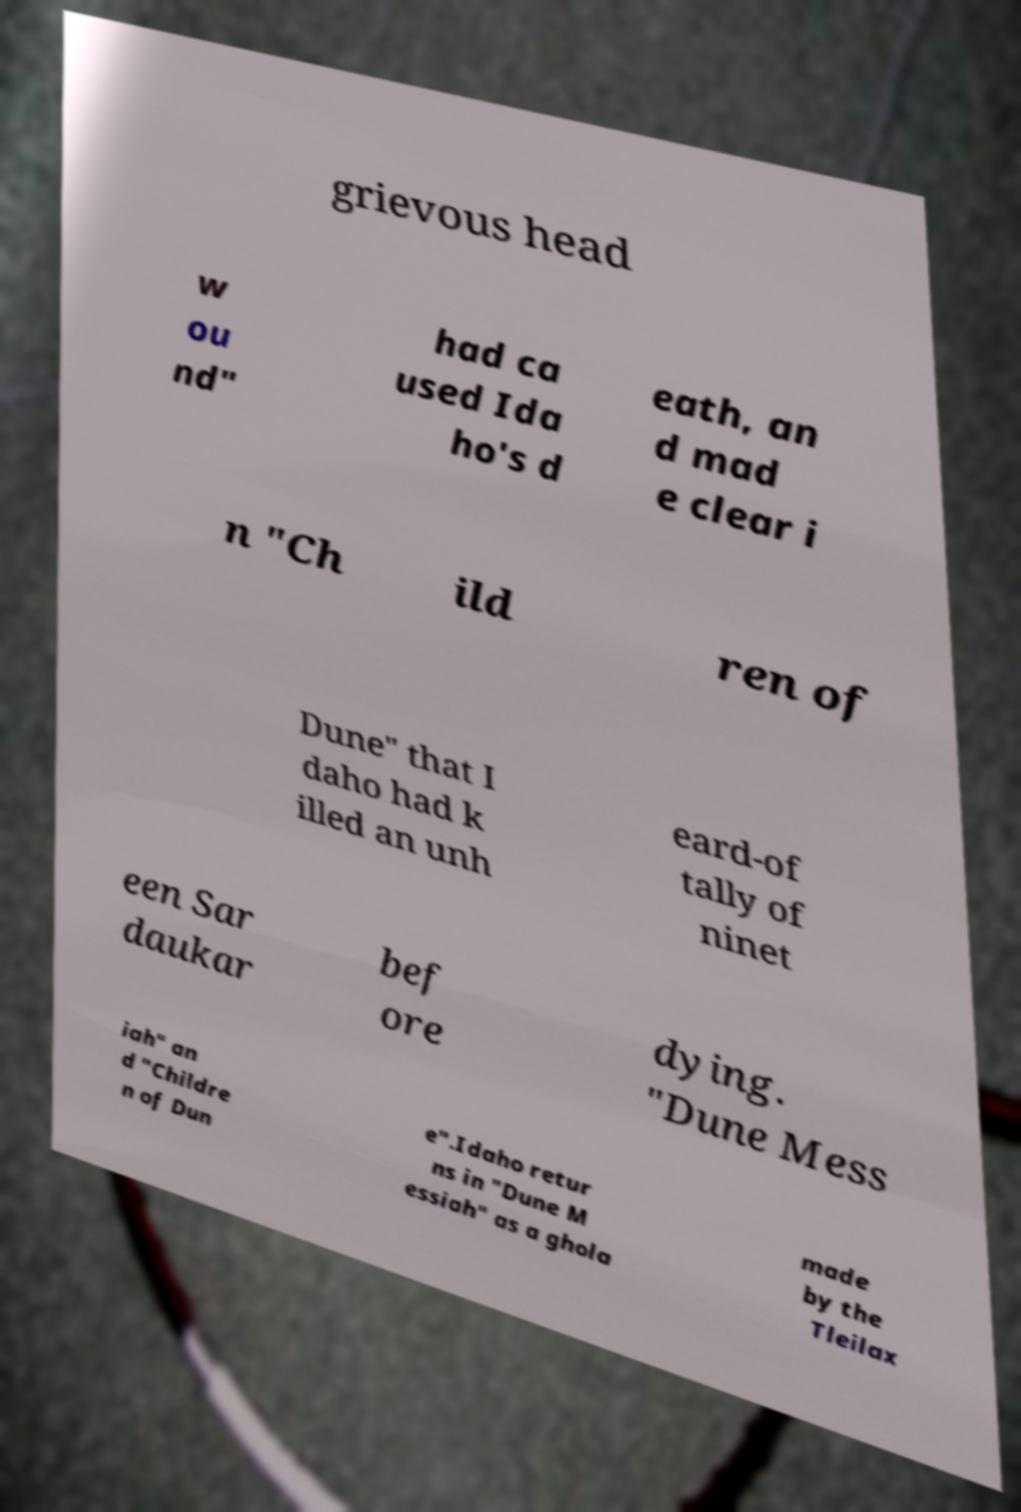Can you accurately transcribe the text from the provided image for me? grievous head w ou nd" had ca used Ida ho's d eath, an d mad e clear i n "Ch ild ren of Dune" that I daho had k illed an unh eard-of tally of ninet een Sar daukar bef ore dying. "Dune Mess iah" an d "Childre n of Dun e".Idaho retur ns in "Dune M essiah" as a ghola made by the Tleilax 